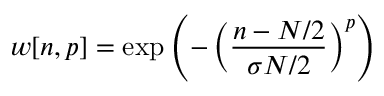Convert formula to latex. <formula><loc_0><loc_0><loc_500><loc_500>w [ n , p ] = \exp \left ( - \left ( { \frac { n - N / 2 } { \sigma N / 2 } } \right ) ^ { p } \right )</formula> 